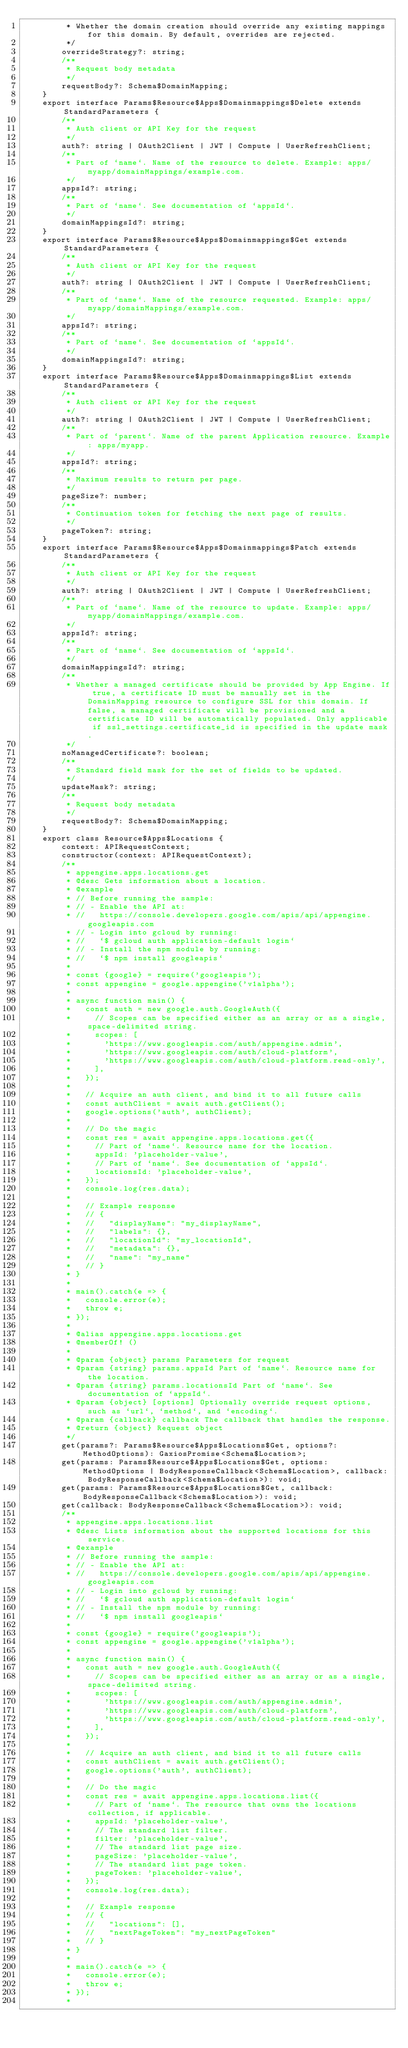<code> <loc_0><loc_0><loc_500><loc_500><_TypeScript_>         * Whether the domain creation should override any existing mappings for this domain. By default, overrides are rejected.
         */
        overrideStrategy?: string;
        /**
         * Request body metadata
         */
        requestBody?: Schema$DomainMapping;
    }
    export interface Params$Resource$Apps$Domainmappings$Delete extends StandardParameters {
        /**
         * Auth client or API Key for the request
         */
        auth?: string | OAuth2Client | JWT | Compute | UserRefreshClient;
        /**
         * Part of `name`. Name of the resource to delete. Example: apps/myapp/domainMappings/example.com.
         */
        appsId?: string;
        /**
         * Part of `name`. See documentation of `appsId`.
         */
        domainMappingsId?: string;
    }
    export interface Params$Resource$Apps$Domainmappings$Get extends StandardParameters {
        /**
         * Auth client or API Key for the request
         */
        auth?: string | OAuth2Client | JWT | Compute | UserRefreshClient;
        /**
         * Part of `name`. Name of the resource requested. Example: apps/myapp/domainMappings/example.com.
         */
        appsId?: string;
        /**
         * Part of `name`. See documentation of `appsId`.
         */
        domainMappingsId?: string;
    }
    export interface Params$Resource$Apps$Domainmappings$List extends StandardParameters {
        /**
         * Auth client or API Key for the request
         */
        auth?: string | OAuth2Client | JWT | Compute | UserRefreshClient;
        /**
         * Part of `parent`. Name of the parent Application resource. Example: apps/myapp.
         */
        appsId?: string;
        /**
         * Maximum results to return per page.
         */
        pageSize?: number;
        /**
         * Continuation token for fetching the next page of results.
         */
        pageToken?: string;
    }
    export interface Params$Resource$Apps$Domainmappings$Patch extends StandardParameters {
        /**
         * Auth client or API Key for the request
         */
        auth?: string | OAuth2Client | JWT | Compute | UserRefreshClient;
        /**
         * Part of `name`. Name of the resource to update. Example: apps/myapp/domainMappings/example.com.
         */
        appsId?: string;
        /**
         * Part of `name`. See documentation of `appsId`.
         */
        domainMappingsId?: string;
        /**
         * Whether a managed certificate should be provided by App Engine. If true, a certificate ID must be manually set in the DomainMapping resource to configure SSL for this domain. If false, a managed certificate will be provisioned and a certificate ID will be automatically populated. Only applicable if ssl_settings.certificate_id is specified in the update mask.
         */
        noManagedCertificate?: boolean;
        /**
         * Standard field mask for the set of fields to be updated.
         */
        updateMask?: string;
        /**
         * Request body metadata
         */
        requestBody?: Schema$DomainMapping;
    }
    export class Resource$Apps$Locations {
        context: APIRequestContext;
        constructor(context: APIRequestContext);
        /**
         * appengine.apps.locations.get
         * @desc Gets information about a location.
         * @example
         * // Before running the sample:
         * // - Enable the API at:
         * //   https://console.developers.google.com/apis/api/appengine.googleapis.com
         * // - Login into gcloud by running:
         * //   `$ gcloud auth application-default login`
         * // - Install the npm module by running:
         * //   `$ npm install googleapis`
         *
         * const {google} = require('googleapis');
         * const appengine = google.appengine('v1alpha');
         *
         * async function main() {
         *   const auth = new google.auth.GoogleAuth({
         *     // Scopes can be specified either as an array or as a single, space-delimited string.
         *     scopes: [
         *       'https://www.googleapis.com/auth/appengine.admin',
         *       'https://www.googleapis.com/auth/cloud-platform',
         *       'https://www.googleapis.com/auth/cloud-platform.read-only',
         *     ],
         *   });
         *
         *   // Acquire an auth client, and bind it to all future calls
         *   const authClient = await auth.getClient();
         *   google.options('auth', authClient);
         *
         *   // Do the magic
         *   const res = await appengine.apps.locations.get({
         *     // Part of `name`. Resource name for the location.
         *     appsId: 'placeholder-value',
         *     // Part of `name`. See documentation of `appsId`.
         *     locationsId: 'placeholder-value',
         *   });
         *   console.log(res.data);
         *
         *   // Example response
         *   // {
         *   //   "displayName": "my_displayName",
         *   //   "labels": {},
         *   //   "locationId": "my_locationId",
         *   //   "metadata": {},
         *   //   "name": "my_name"
         *   // }
         * }
         *
         * main().catch(e => {
         *   console.error(e);
         *   throw e;
         * });
         *
         * @alias appengine.apps.locations.get
         * @memberOf! ()
         *
         * @param {object} params Parameters for request
         * @param {string} params.appsId Part of `name`. Resource name for the location.
         * @param {string} params.locationsId Part of `name`. See documentation of `appsId`.
         * @param {object} [options] Optionally override request options, such as `url`, `method`, and `encoding`.
         * @param {callback} callback The callback that handles the response.
         * @return {object} Request object
         */
        get(params?: Params$Resource$Apps$Locations$Get, options?: MethodOptions): GaxiosPromise<Schema$Location>;
        get(params: Params$Resource$Apps$Locations$Get, options: MethodOptions | BodyResponseCallback<Schema$Location>, callback: BodyResponseCallback<Schema$Location>): void;
        get(params: Params$Resource$Apps$Locations$Get, callback: BodyResponseCallback<Schema$Location>): void;
        get(callback: BodyResponseCallback<Schema$Location>): void;
        /**
         * appengine.apps.locations.list
         * @desc Lists information about the supported locations for this service.
         * @example
         * // Before running the sample:
         * // - Enable the API at:
         * //   https://console.developers.google.com/apis/api/appengine.googleapis.com
         * // - Login into gcloud by running:
         * //   `$ gcloud auth application-default login`
         * // - Install the npm module by running:
         * //   `$ npm install googleapis`
         *
         * const {google} = require('googleapis');
         * const appengine = google.appengine('v1alpha');
         *
         * async function main() {
         *   const auth = new google.auth.GoogleAuth({
         *     // Scopes can be specified either as an array or as a single, space-delimited string.
         *     scopes: [
         *       'https://www.googleapis.com/auth/appengine.admin',
         *       'https://www.googleapis.com/auth/cloud-platform',
         *       'https://www.googleapis.com/auth/cloud-platform.read-only',
         *     ],
         *   });
         *
         *   // Acquire an auth client, and bind it to all future calls
         *   const authClient = await auth.getClient();
         *   google.options('auth', authClient);
         *
         *   // Do the magic
         *   const res = await appengine.apps.locations.list({
         *     // Part of `name`. The resource that owns the locations collection, if applicable.
         *     appsId: 'placeholder-value',
         *     // The standard list filter.
         *     filter: 'placeholder-value',
         *     // The standard list page size.
         *     pageSize: 'placeholder-value',
         *     // The standard list page token.
         *     pageToken: 'placeholder-value',
         *   });
         *   console.log(res.data);
         *
         *   // Example response
         *   // {
         *   //   "locations": [],
         *   //   "nextPageToken": "my_nextPageToken"
         *   // }
         * }
         *
         * main().catch(e => {
         *   console.error(e);
         *   throw e;
         * });
         *</code> 